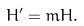<formula> <loc_0><loc_0><loc_500><loc_500>H ^ { \prime } = m H .</formula> 